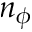<formula> <loc_0><loc_0><loc_500><loc_500>n _ { \phi }</formula> 